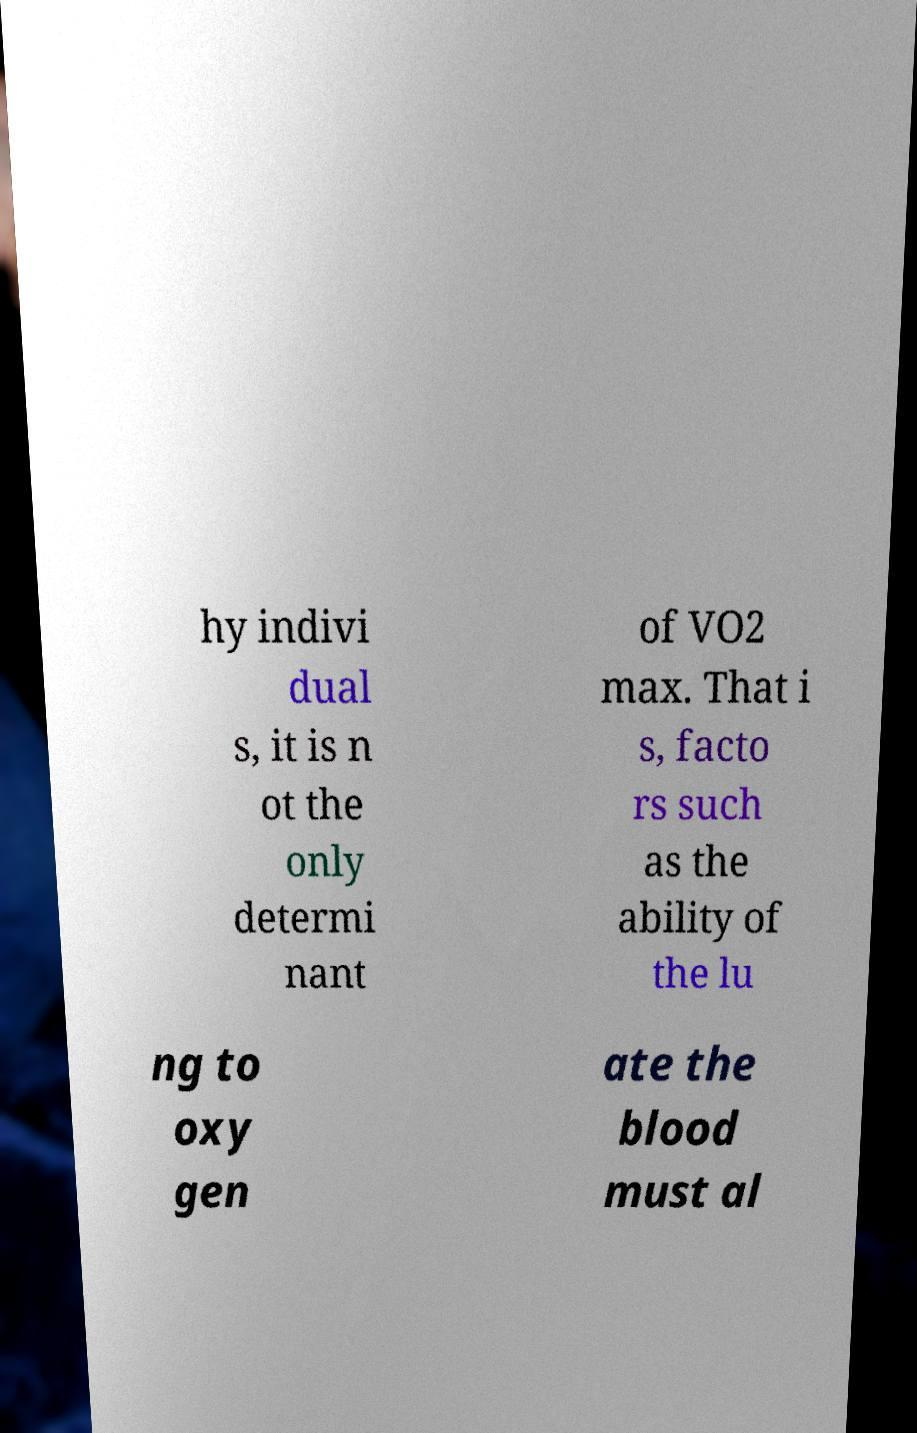Please identify and transcribe the text found in this image. hy indivi dual s, it is n ot the only determi nant of VO2 max. That i s, facto rs such as the ability of the lu ng to oxy gen ate the blood must al 